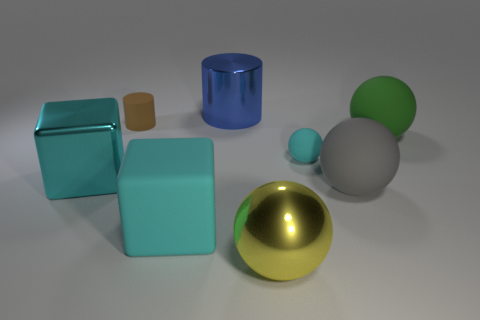Subtract all big metal balls. How many balls are left? 3 Subtract all red blocks. How many purple spheres are left? 0 Add 1 rubber blocks. How many objects exist? 9 Subtract all yellow spheres. How many spheres are left? 3 Subtract all blocks. How many objects are left? 6 Subtract 3 balls. How many balls are left? 1 Subtract all red cubes. Subtract all green cylinders. How many cubes are left? 2 Subtract all small cylinders. Subtract all balls. How many objects are left? 3 Add 5 big blue metal objects. How many big blue metal objects are left? 6 Add 8 cyan spheres. How many cyan spheres exist? 9 